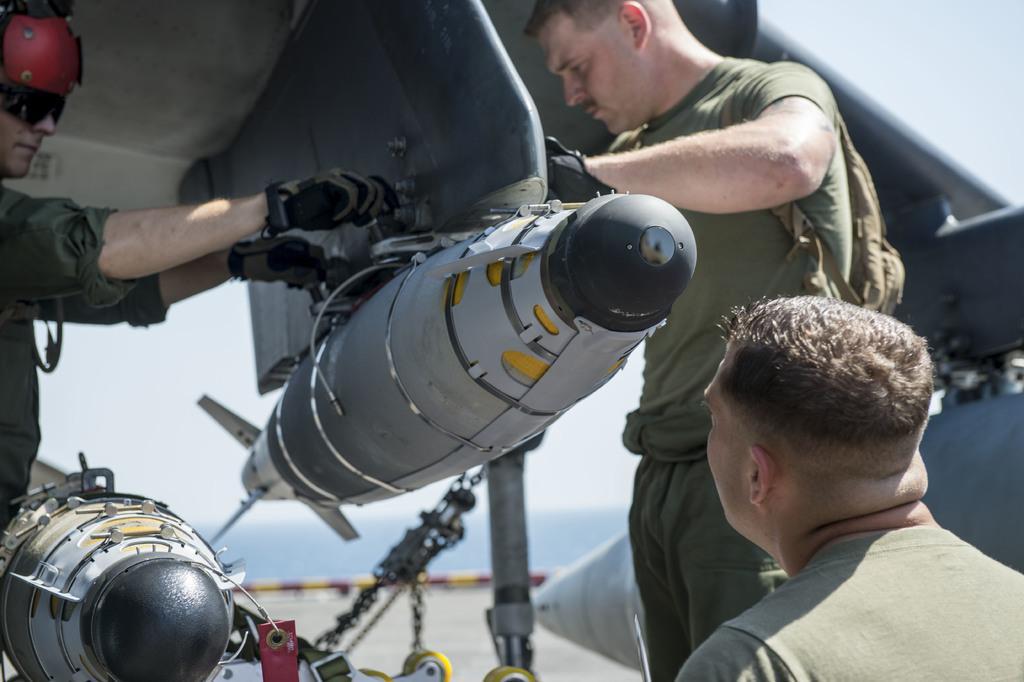Could you give a brief overview of what you see in this image? In the foreground I can see a vehicle, three persons and some objects on the road. In the background I can see mountains and the sky. This image is taken may be during a day. 